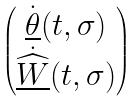<formula> <loc_0><loc_0><loc_500><loc_500>\begin{pmatrix} \dot { \underline { \theta } } ( t , \sigma ) \\ \dot { \widehat { \underline { W } } } ( t , \sigma ) \end{pmatrix}</formula> 